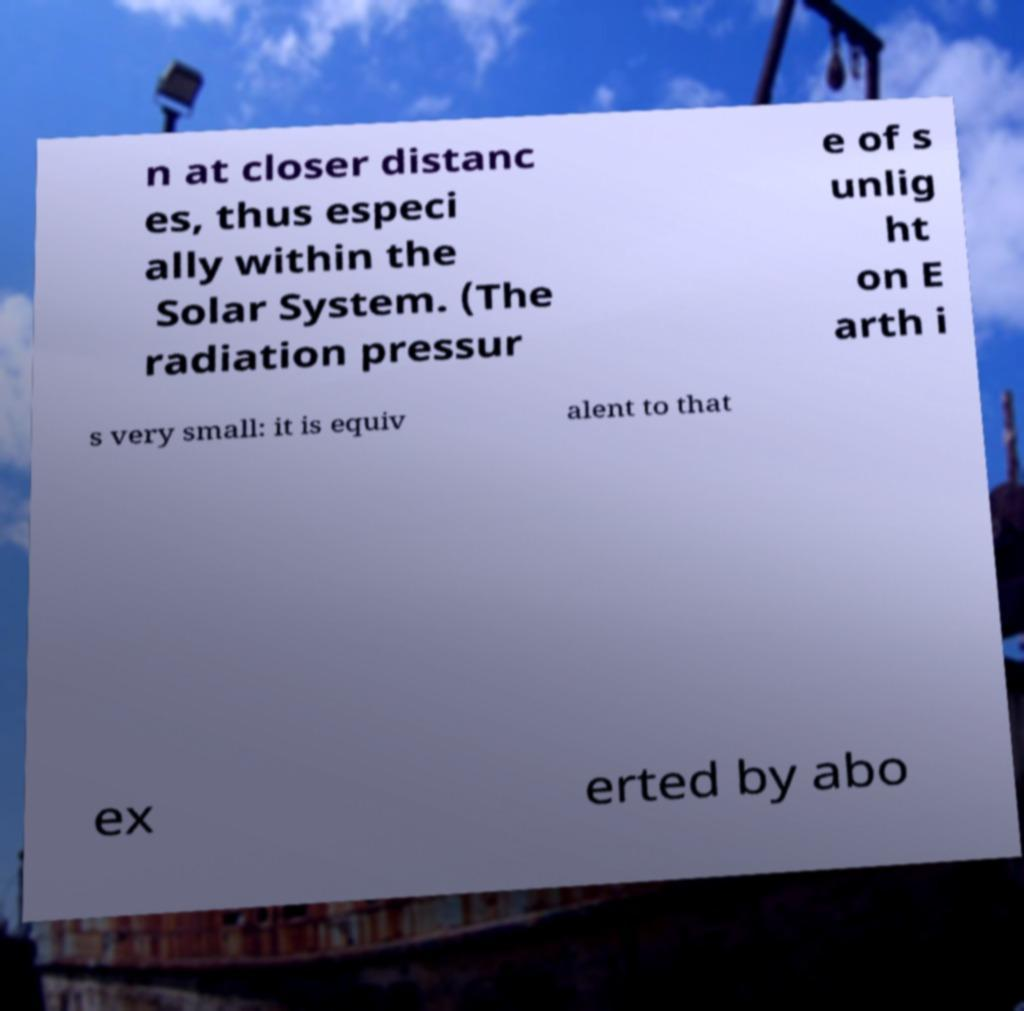Please read and relay the text visible in this image. What does it say? n at closer distanc es, thus especi ally within the Solar System. (The radiation pressur e of s unlig ht on E arth i s very small: it is equiv alent to that ex erted by abo 